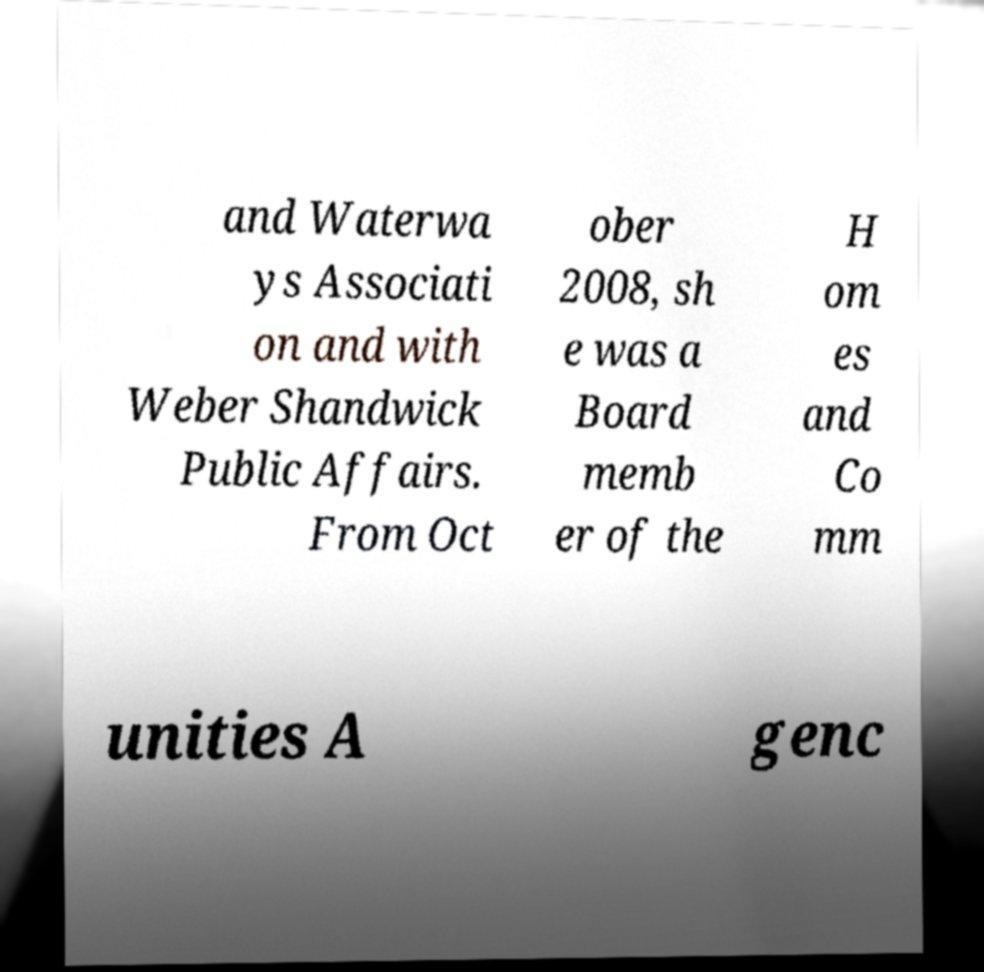For documentation purposes, I need the text within this image transcribed. Could you provide that? and Waterwa ys Associati on and with Weber Shandwick Public Affairs. From Oct ober 2008, sh e was a Board memb er of the H om es and Co mm unities A genc 